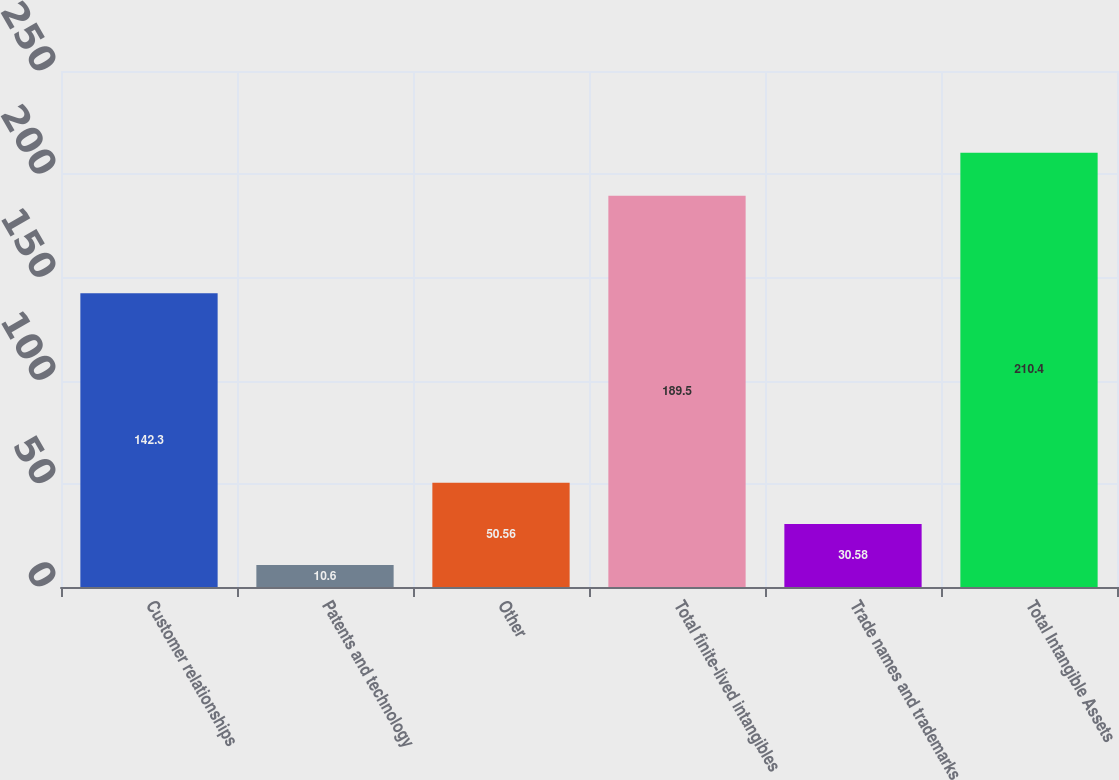<chart> <loc_0><loc_0><loc_500><loc_500><bar_chart><fcel>Customer relationships<fcel>Patents and technology<fcel>Other<fcel>Total finite-lived intangibles<fcel>Trade names and trademarks<fcel>Total Intangible Assets<nl><fcel>142.3<fcel>10.6<fcel>50.56<fcel>189.5<fcel>30.58<fcel>210.4<nl></chart> 